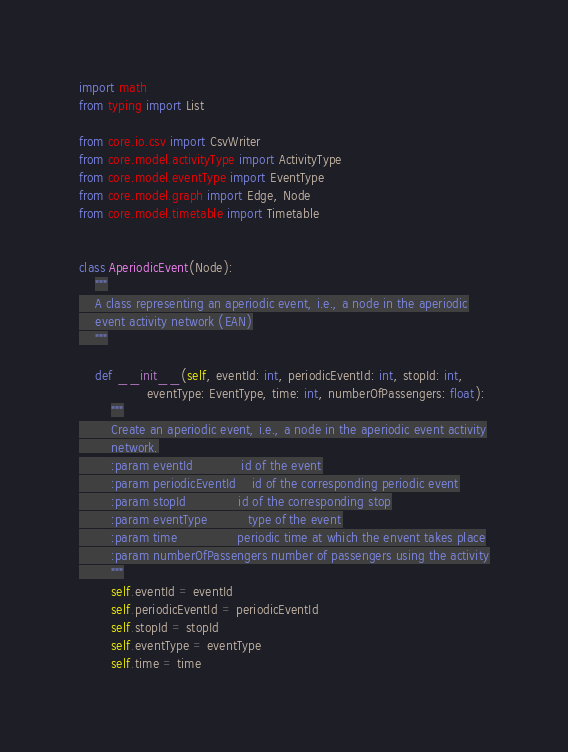Convert code to text. <code><loc_0><loc_0><loc_500><loc_500><_Python_>import math
from typing import List

from core.io.csv import CsvWriter
from core.model.activityType import ActivityType
from core.model.eventType import EventType
from core.model.graph import Edge, Node
from core.model.timetable import Timetable


class AperiodicEvent(Node):
    """
    A class representing an aperiodic event, i.e., a node in the aperiodic
    event activity network (EAN)
    """

    def __init__(self, eventId: int, periodicEventId: int, stopId: int,
                 eventType: EventType, time: int, numberOfPassengers: float):
        """
        Create an aperiodic event, i.e., a node in the aperiodic event activity
        network.
        :param eventId            id of the event
        :param periodicEventId    id of the corresponding periodic event
        :param stopId             id of the corresponding stop
        :param eventType          type of the event
        :param time               periodic time at which the envent takes place
        :param numberOfPassengers number of passengers using the activity
        """
        self.eventId = eventId
        self.periodicEventId = periodicEventId
        self.stopId = stopId
        self.eventType = eventType
        self.time = time</code> 